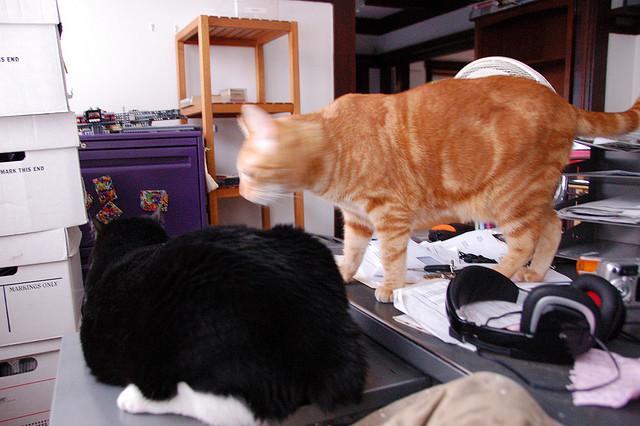Where is the headphones?
Short answer required. On desk. Which cat has "Irish" colored hair?
Short answer required. One on right. How many boxes are stacked on top of one another?
Give a very brief answer. 4. 